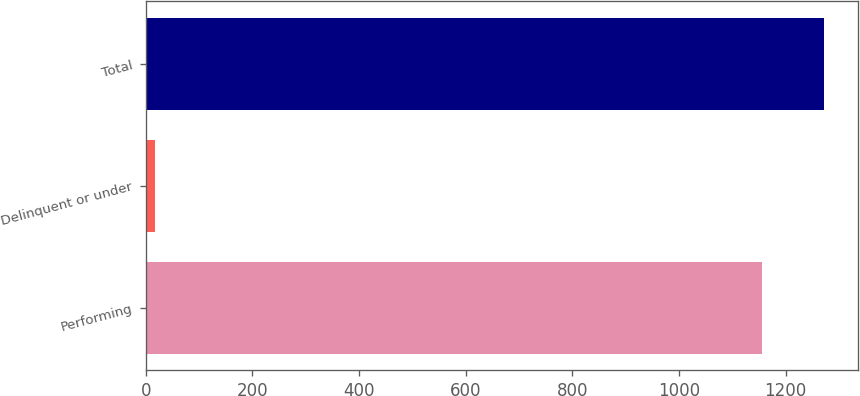Convert chart. <chart><loc_0><loc_0><loc_500><loc_500><bar_chart><fcel>Performing<fcel>Delinquent or under<fcel>Total<nl><fcel>1155<fcel>18<fcel>1272.2<nl></chart> 